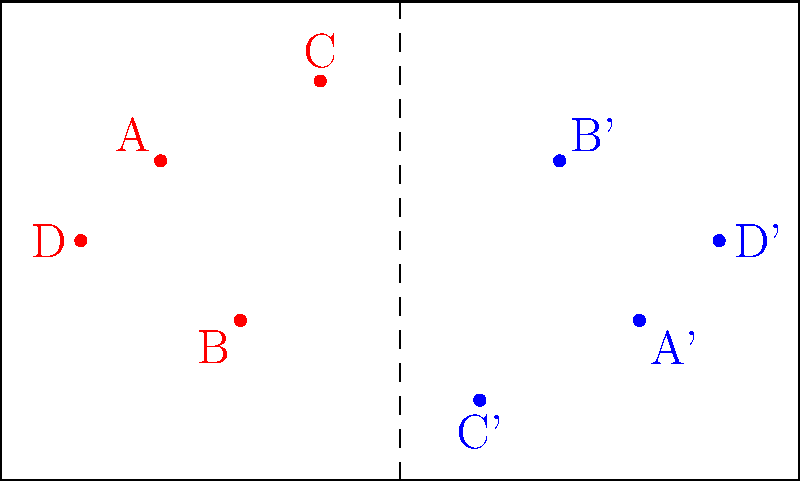In a local football match in Makamba County, the coach wants to practice a defensive strategy by reflecting the team's formation across the center line of the pitch. Given the original positions of players A(-3,1), B(-2,-1), C(-1,2), and D(-4,0), what are the coordinates of player C' after reflection? To find the coordinates of player C' after reflection across the center line (y-axis), we follow these steps:

1) The center line of the pitch acts as the line of reflection (y-axis).

2) When reflecting a point across the y-axis, the x-coordinate changes sign, while the y-coordinate remains the same.

3) The original coordinates of player C are (-1,2).

4) To reflect:
   - The x-coordinate changes from -1 to 1
   - The y-coordinate remains 2

5) Therefore, the coordinates of C' after reflection are (1,-2).

Note: The negative y-coordinate represents the opposite side of the pitch relative to the original position.
Answer: (1,-2) 